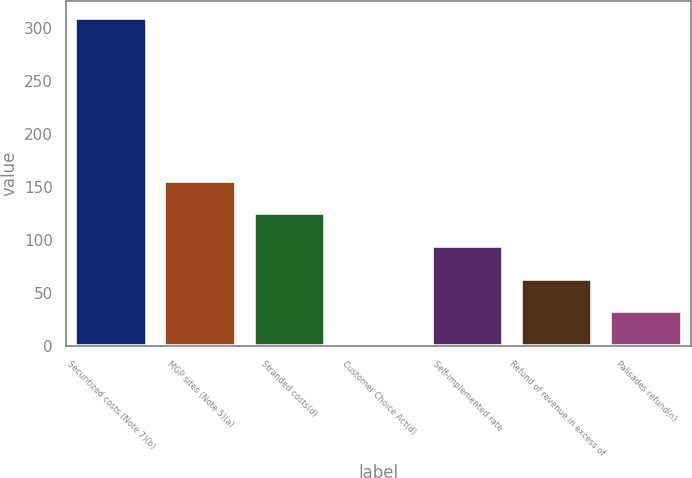Convert chart to OTSL. <chart><loc_0><loc_0><loc_500><loc_500><bar_chart><fcel>Securitized costs (Note 7)(b)<fcel>MGP sites (Note 5)(a)<fcel>Stranded costs(d)<fcel>Customer Choice Act(d)<fcel>Self-implemented rate<fcel>Refund of revenue in excess of<fcel>Palisades refund(n)<nl><fcel>310<fcel>156<fcel>125.2<fcel>2<fcel>94.4<fcel>63.6<fcel>32.8<nl></chart> 